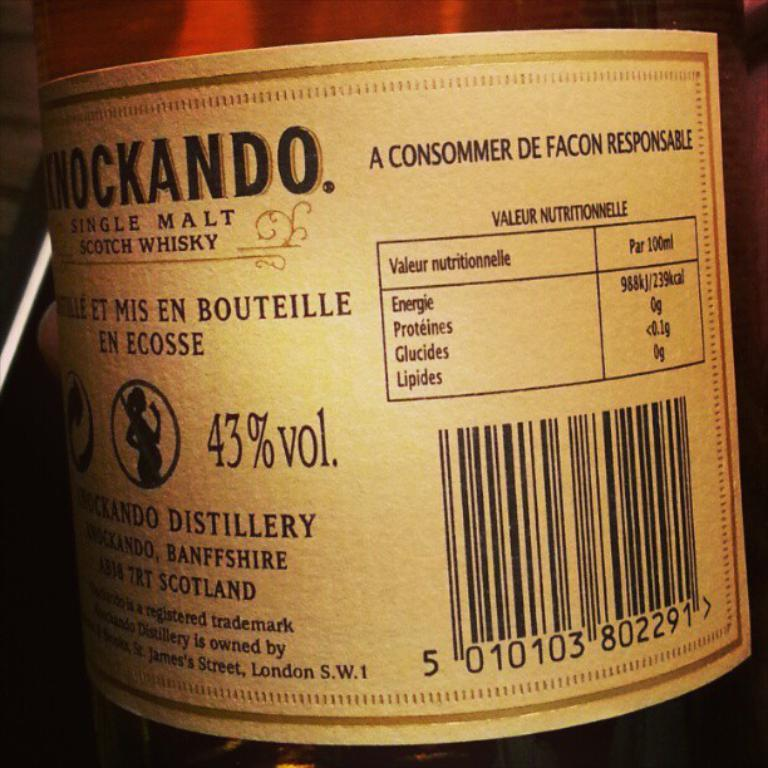<image>
Render a clear and concise summary of the photo. The label on a bottle of single malt scotch whisky claims 43% alcohol by volume. 